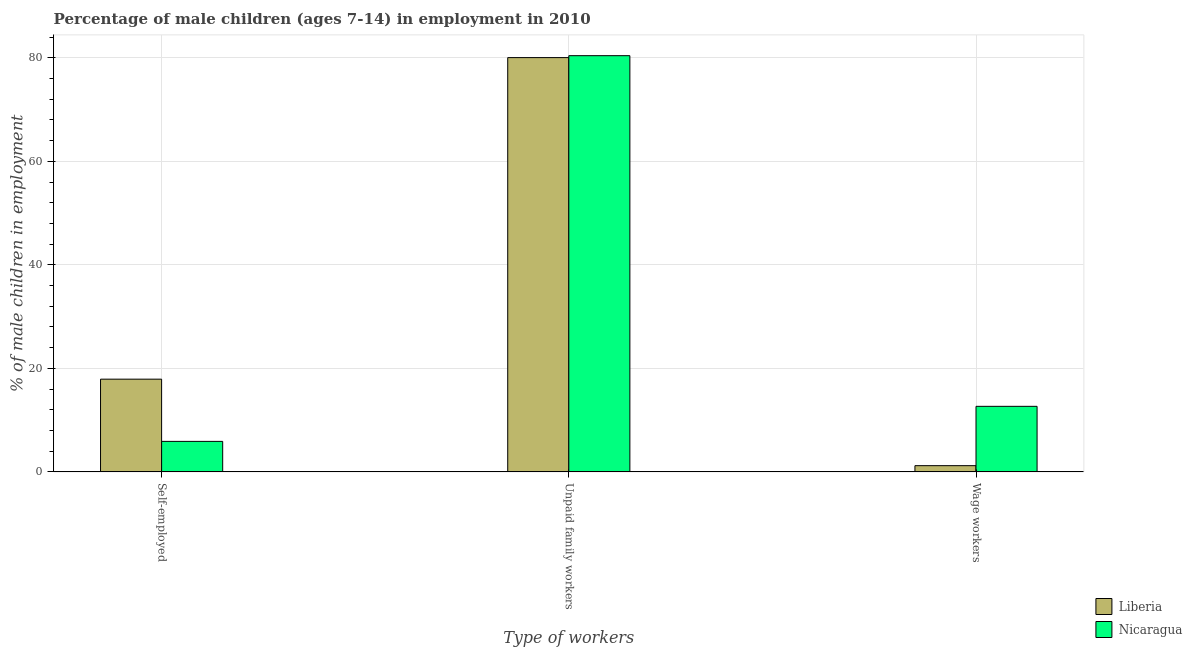How many groups of bars are there?
Make the answer very short. 3. Are the number of bars per tick equal to the number of legend labels?
Offer a very short reply. Yes. Are the number of bars on each tick of the X-axis equal?
Ensure brevity in your answer.  Yes. How many bars are there on the 3rd tick from the left?
Your answer should be very brief. 2. How many bars are there on the 3rd tick from the right?
Your answer should be very brief. 2. What is the label of the 2nd group of bars from the left?
Provide a succinct answer. Unpaid family workers. Across all countries, what is the maximum percentage of children employed as wage workers?
Keep it short and to the point. 12.67. Across all countries, what is the minimum percentage of children employed as wage workers?
Ensure brevity in your answer.  1.21. In which country was the percentage of children employed as unpaid family workers maximum?
Provide a succinct answer. Nicaragua. In which country was the percentage of children employed as wage workers minimum?
Offer a terse response. Liberia. What is the total percentage of self employed children in the graph?
Your answer should be compact. 23.82. What is the difference between the percentage of self employed children in Liberia and that in Nicaragua?
Your response must be concise. 12.02. What is the difference between the percentage of children employed as wage workers in Nicaragua and the percentage of children employed as unpaid family workers in Liberia?
Provide a succinct answer. -67.36. What is the average percentage of children employed as wage workers per country?
Make the answer very short. 6.94. What is the difference between the percentage of children employed as unpaid family workers and percentage of children employed as wage workers in Liberia?
Your answer should be compact. 78.82. What is the ratio of the percentage of children employed as unpaid family workers in Liberia to that in Nicaragua?
Provide a succinct answer. 1. Is the percentage of self employed children in Liberia less than that in Nicaragua?
Ensure brevity in your answer.  No. What is the difference between the highest and the second highest percentage of children employed as wage workers?
Your response must be concise. 11.46. What is the difference between the highest and the lowest percentage of self employed children?
Your answer should be very brief. 12.02. Is the sum of the percentage of self employed children in Nicaragua and Liberia greater than the maximum percentage of children employed as wage workers across all countries?
Give a very brief answer. Yes. What does the 1st bar from the left in Unpaid family workers represents?
Your response must be concise. Liberia. What does the 1st bar from the right in Self-employed represents?
Keep it short and to the point. Nicaragua. Are all the bars in the graph horizontal?
Offer a very short reply. No. How many countries are there in the graph?
Ensure brevity in your answer.  2. What is the difference between two consecutive major ticks on the Y-axis?
Provide a short and direct response. 20. Does the graph contain any zero values?
Offer a very short reply. No. Where does the legend appear in the graph?
Give a very brief answer. Bottom right. What is the title of the graph?
Your answer should be compact. Percentage of male children (ages 7-14) in employment in 2010. Does "American Samoa" appear as one of the legend labels in the graph?
Ensure brevity in your answer.  No. What is the label or title of the X-axis?
Ensure brevity in your answer.  Type of workers. What is the label or title of the Y-axis?
Offer a terse response. % of male children in employment. What is the % of male children in employment of Liberia in Self-employed?
Give a very brief answer. 17.92. What is the % of male children in employment of Liberia in Unpaid family workers?
Offer a terse response. 80.03. What is the % of male children in employment in Nicaragua in Unpaid family workers?
Your response must be concise. 80.4. What is the % of male children in employment in Liberia in Wage workers?
Provide a short and direct response. 1.21. What is the % of male children in employment in Nicaragua in Wage workers?
Provide a succinct answer. 12.67. Across all Type of workers, what is the maximum % of male children in employment of Liberia?
Provide a succinct answer. 80.03. Across all Type of workers, what is the maximum % of male children in employment of Nicaragua?
Ensure brevity in your answer.  80.4. Across all Type of workers, what is the minimum % of male children in employment of Liberia?
Your answer should be compact. 1.21. Across all Type of workers, what is the minimum % of male children in employment in Nicaragua?
Provide a succinct answer. 5.9. What is the total % of male children in employment in Liberia in the graph?
Ensure brevity in your answer.  99.16. What is the total % of male children in employment of Nicaragua in the graph?
Your response must be concise. 98.97. What is the difference between the % of male children in employment in Liberia in Self-employed and that in Unpaid family workers?
Make the answer very short. -62.11. What is the difference between the % of male children in employment of Nicaragua in Self-employed and that in Unpaid family workers?
Provide a short and direct response. -74.5. What is the difference between the % of male children in employment of Liberia in Self-employed and that in Wage workers?
Your response must be concise. 16.71. What is the difference between the % of male children in employment of Nicaragua in Self-employed and that in Wage workers?
Ensure brevity in your answer.  -6.77. What is the difference between the % of male children in employment in Liberia in Unpaid family workers and that in Wage workers?
Your answer should be compact. 78.82. What is the difference between the % of male children in employment in Nicaragua in Unpaid family workers and that in Wage workers?
Offer a terse response. 67.73. What is the difference between the % of male children in employment of Liberia in Self-employed and the % of male children in employment of Nicaragua in Unpaid family workers?
Your response must be concise. -62.48. What is the difference between the % of male children in employment in Liberia in Self-employed and the % of male children in employment in Nicaragua in Wage workers?
Make the answer very short. 5.25. What is the difference between the % of male children in employment in Liberia in Unpaid family workers and the % of male children in employment in Nicaragua in Wage workers?
Your answer should be compact. 67.36. What is the average % of male children in employment in Liberia per Type of workers?
Give a very brief answer. 33.05. What is the average % of male children in employment in Nicaragua per Type of workers?
Your response must be concise. 32.99. What is the difference between the % of male children in employment of Liberia and % of male children in employment of Nicaragua in Self-employed?
Keep it short and to the point. 12.02. What is the difference between the % of male children in employment of Liberia and % of male children in employment of Nicaragua in Unpaid family workers?
Ensure brevity in your answer.  -0.37. What is the difference between the % of male children in employment of Liberia and % of male children in employment of Nicaragua in Wage workers?
Your answer should be compact. -11.46. What is the ratio of the % of male children in employment of Liberia in Self-employed to that in Unpaid family workers?
Make the answer very short. 0.22. What is the ratio of the % of male children in employment in Nicaragua in Self-employed to that in Unpaid family workers?
Give a very brief answer. 0.07. What is the ratio of the % of male children in employment of Liberia in Self-employed to that in Wage workers?
Make the answer very short. 14.81. What is the ratio of the % of male children in employment of Nicaragua in Self-employed to that in Wage workers?
Ensure brevity in your answer.  0.47. What is the ratio of the % of male children in employment of Liberia in Unpaid family workers to that in Wage workers?
Your response must be concise. 66.14. What is the ratio of the % of male children in employment in Nicaragua in Unpaid family workers to that in Wage workers?
Keep it short and to the point. 6.35. What is the difference between the highest and the second highest % of male children in employment in Liberia?
Offer a terse response. 62.11. What is the difference between the highest and the second highest % of male children in employment in Nicaragua?
Your response must be concise. 67.73. What is the difference between the highest and the lowest % of male children in employment in Liberia?
Keep it short and to the point. 78.82. What is the difference between the highest and the lowest % of male children in employment of Nicaragua?
Provide a short and direct response. 74.5. 